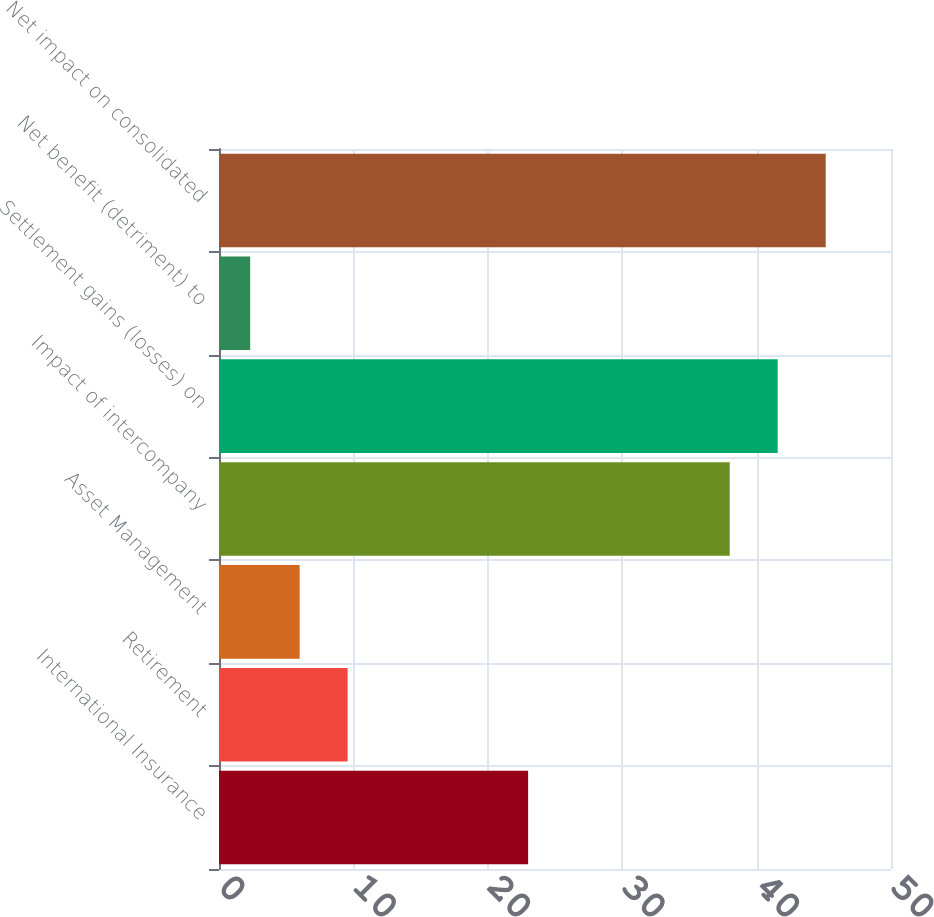<chart> <loc_0><loc_0><loc_500><loc_500><bar_chart><fcel>International Insurance<fcel>Retirement<fcel>Asset Management<fcel>Impact of intercompany<fcel>Settlement gains (losses) on<fcel>Net benefit (detriment) to<fcel>Net impact on consolidated<nl><fcel>23<fcel>9.57<fcel>6<fcel>38<fcel>41.57<fcel>2.32<fcel>45.14<nl></chart> 